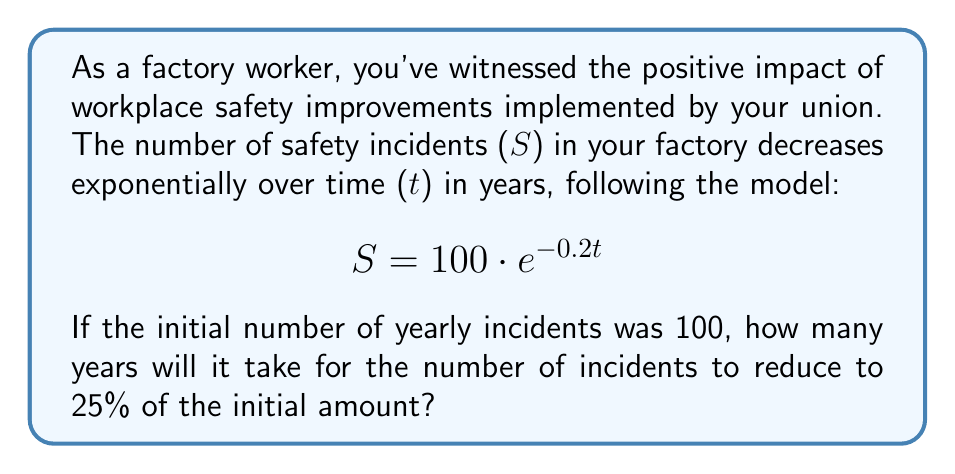Help me with this question. To solve this problem, we need to use the properties of logarithms and exponential functions. Let's approach this step-by-step:

1) We start with the given exponential model:
   $$ S = 100 \cdot e^{-0.2t} $$

2) We want to find when S is 25% of the initial amount, which is 25% of 100, or 25:
   $$ 25 = 100 \cdot e^{-0.2t} $$

3) Divide both sides by 100:
   $$ 0.25 = e^{-0.2t} $$

4) Now, we can take the natural logarithm of both sides:
   $$ \ln(0.25) = \ln(e^{-0.2t}) $$

5) Using the logarithm property $\ln(e^x) = x$, we get:
   $$ \ln(0.25) = -0.2t $$

6) Solve for t:
   $$ t = -\frac{\ln(0.25)}{0.2} $$

7) Calculate the value:
   $$ t = -\frac{\ln(0.25)}{0.2} \approx 6.93 \text{ years} $$

Therefore, it will take approximately 6.93 years for the number of safety incidents to reduce to 25% of the initial amount.
Answer: 6.93 years 